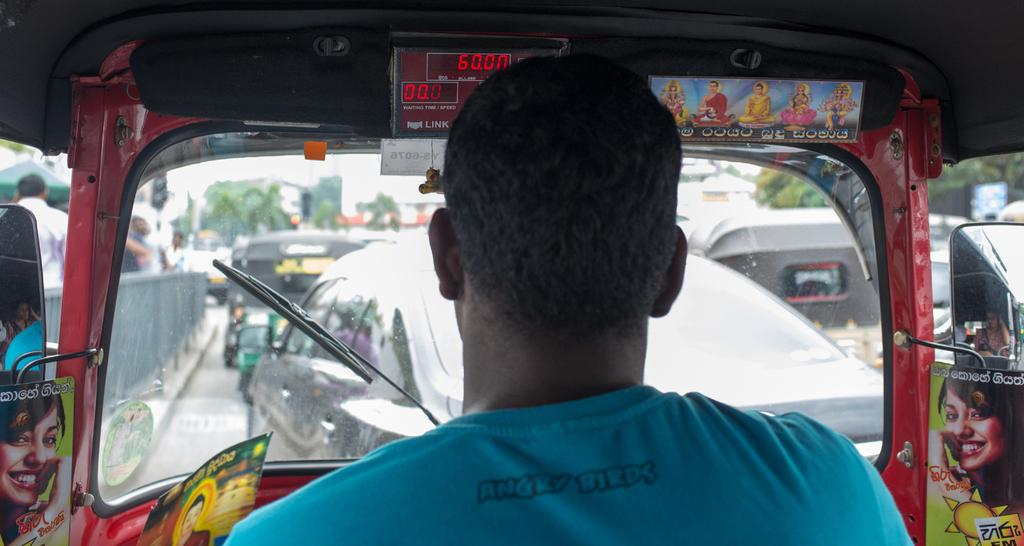What is the person in the image doing? The person is sitting in an auto. What can be seen on the road in the image? Vehicles are parked on the road. What are the people on the side of the road doing? People are standing on the footpath. What type of wool is being used to pave the road in the image? There is no wool present in the image, and the road is not being paved with any material. 